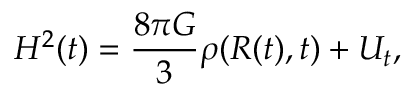<formula> <loc_0><loc_0><loc_500><loc_500>H ^ { 2 } ( t ) = \frac { 8 \pi G } { 3 } \rho ( R ( t ) , t ) + U _ { t } ,</formula> 